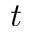Convert formula to latex. <formula><loc_0><loc_0><loc_500><loc_500>t</formula> 